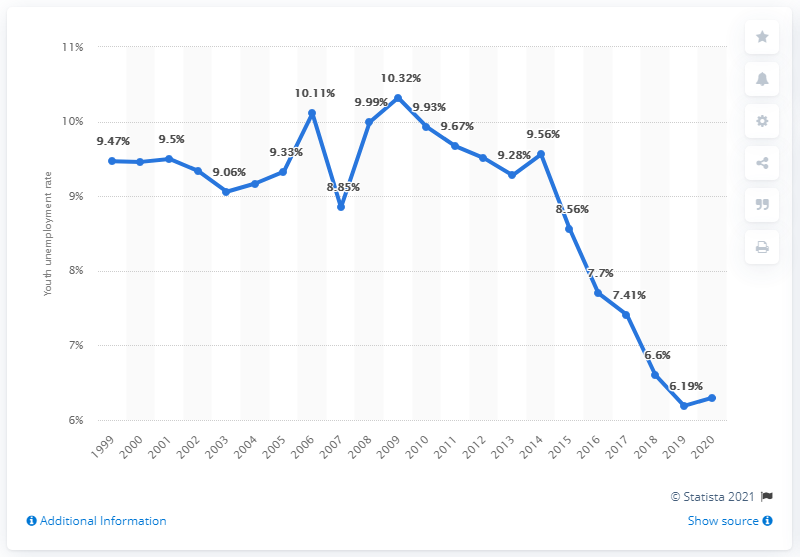Indicate a few pertinent items in this graphic. In 2020, the youth unemployment rate in the Philippines was reported to be 6.3%. 